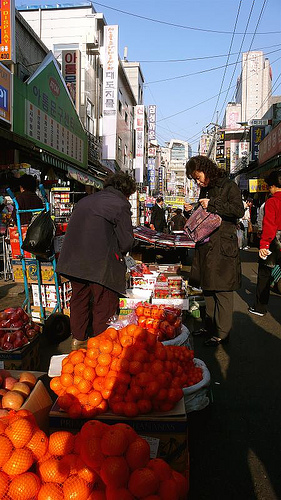Please provide the bounding box coordinate of the region this sentence describes: arm of a person. The coordinates [0.72, 0.41, 0.77, 0.5] represent the arm region, capturing the upper and lower arm but missing a slight portion of the wrist that provides a complete view. 